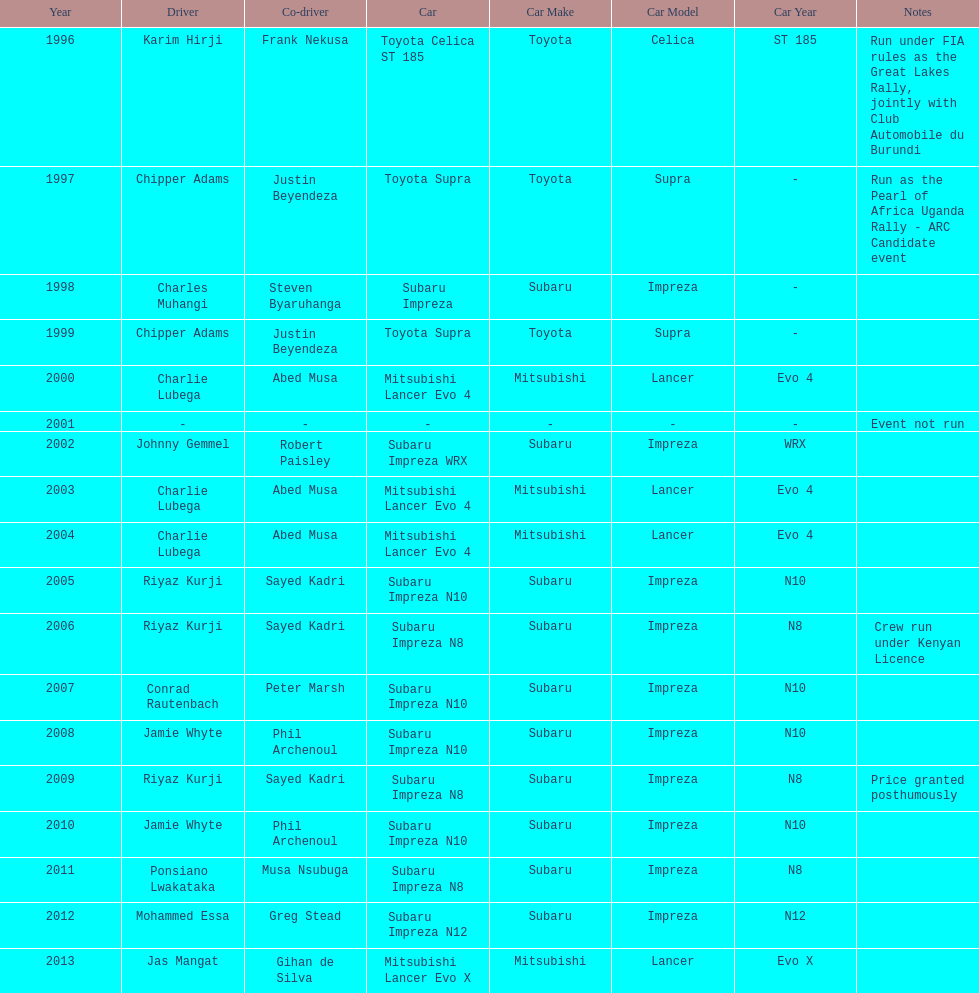How many drivers won at least twice? 4. 